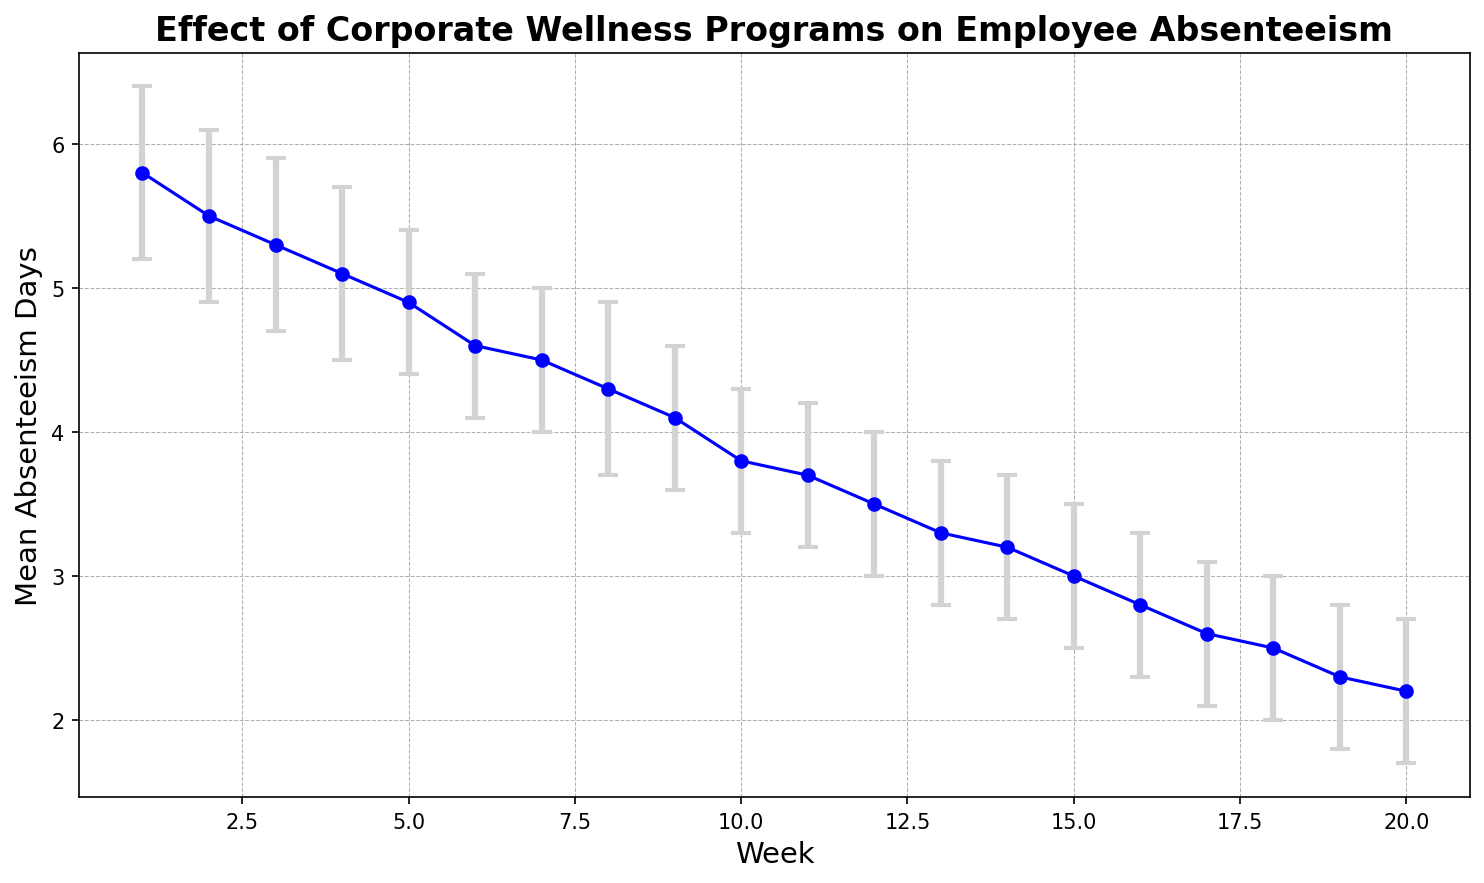What is the mean absenteeism day in Week 1? The graph shows the mean absenteeism days for each week. In Week 1, the value corresponding to the first data point is 5.8 days.
Answer: 5.8 By how many days did absenteeism decrease from Week 1 to Week 10? Identify the mean absenteeism days for Week 1 (5.8 days) and Week 10 (3.8 days), then subtract the Week 10 value from the Week 1 value: 5.8 - 3.8.
Answer: 2.0 What is the average mean absenteeism days from Week 1 to Week 5? Sum the mean absenteeism days for Weeks 1 to 5 and divide by the number of weeks: (5.8 + 5.5 + 5.3 + 5.1 + 4.9) / 5. The calculation is (26.6) / 5.
Answer: 5.32 Which week had the lowest mean absenteeism days? Scan through the graph to identify the week with the lowest point on the plot, which is Week 20. The corresponding value is 2.2 mean absenteeism days.
Answer: Week 20 How does the confidence interval change from Week 1 to Week 20? Observing the plot, the confidence interval narrows over time. Week 1 has larger error bars (5.2 to 6.4) compared to Week 20 (1.7 to 2.7). This indicates the intervals are becoming tighter, reflecting less uncertainty as weeks progress.
Answer: Narrows What is the total decrease in mean absenteeism days from Week 1 to Week 20? Subtract the mean absenteeism days in Week 20 (2.2 days) from those in Week 1 (5.8 days): 5.8 - 2.2.
Answer: 3.6 Is the mean absenteeism in Week 10 greater than that in Week 15? Compare the mean absenteeism days for Week 10 (3.8 days) and Week 15 (3.0 days), where 3.8 is greater than 3.0.
Answer: Yes What is the range of absenteeism days in Week 18? The range is calculated by subtracting the lower confidence interval from the upper confidence interval in Week 18: 3.0 - 2.0.
Answer: 1.0 By how much did the mean absenteeism decrease from Week 5 to Week 6? Determine the mean absenteeism days for Week 5 (4.9 days) and Week 6 (4.6 days), then find the difference: 4.9 - 4.6.
Answer: 0.3 Between which weeks did mean absenteeism show the steepest decline? Analyze the difference between consecutive weeks. The largest drop appears between Week 19 (2.3 days) and Week 20 (2.2 days), indicating a declining trend but similar small drops in other weekly transitions. Reviewing all, the steepest is between Week 16 (2.8 days) and Week 17 (2.6 days).
Answer: Weeks 16 and 17 